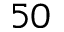<formula> <loc_0><loc_0><loc_500><loc_500>5 0</formula> 